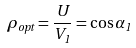<formula> <loc_0><loc_0><loc_500><loc_500>\rho _ { o p t } = \frac { U } { V _ { 1 } } = \cos \alpha _ { 1 }</formula> 